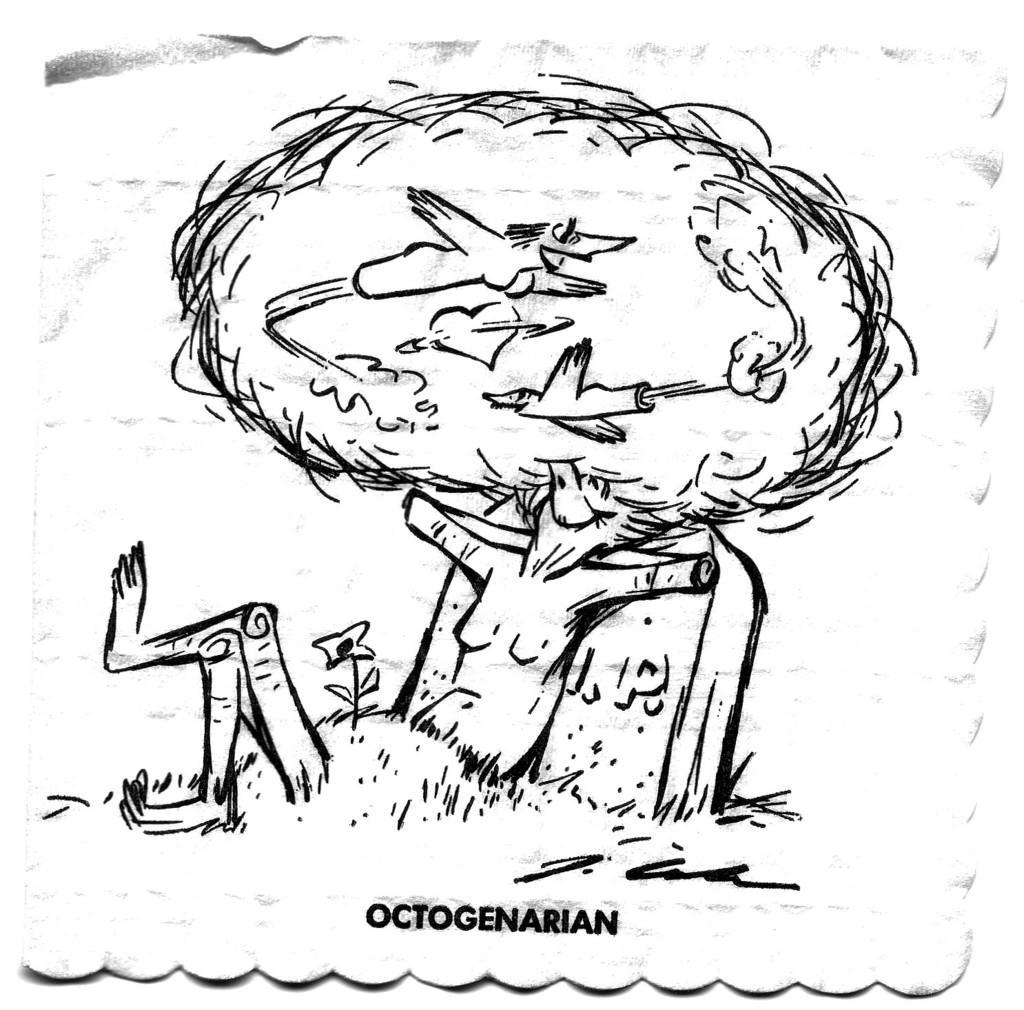Describe this image in one or two sentences. In this picture I can see sketch of person and looks like person is dreaming. 